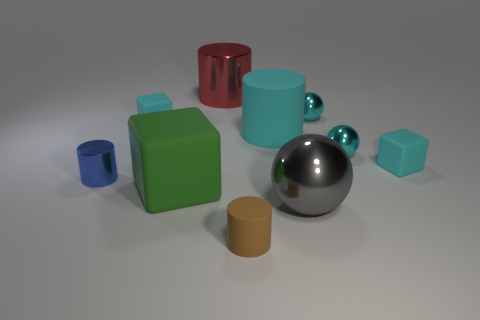Can you describe the texture and appearance of the largest sphere? Certainly, the largest sphere in the image has a glossy, reflective surface that indicates it might be made of a polished metal, possibly stainless steel or a similarly lustrous material. 